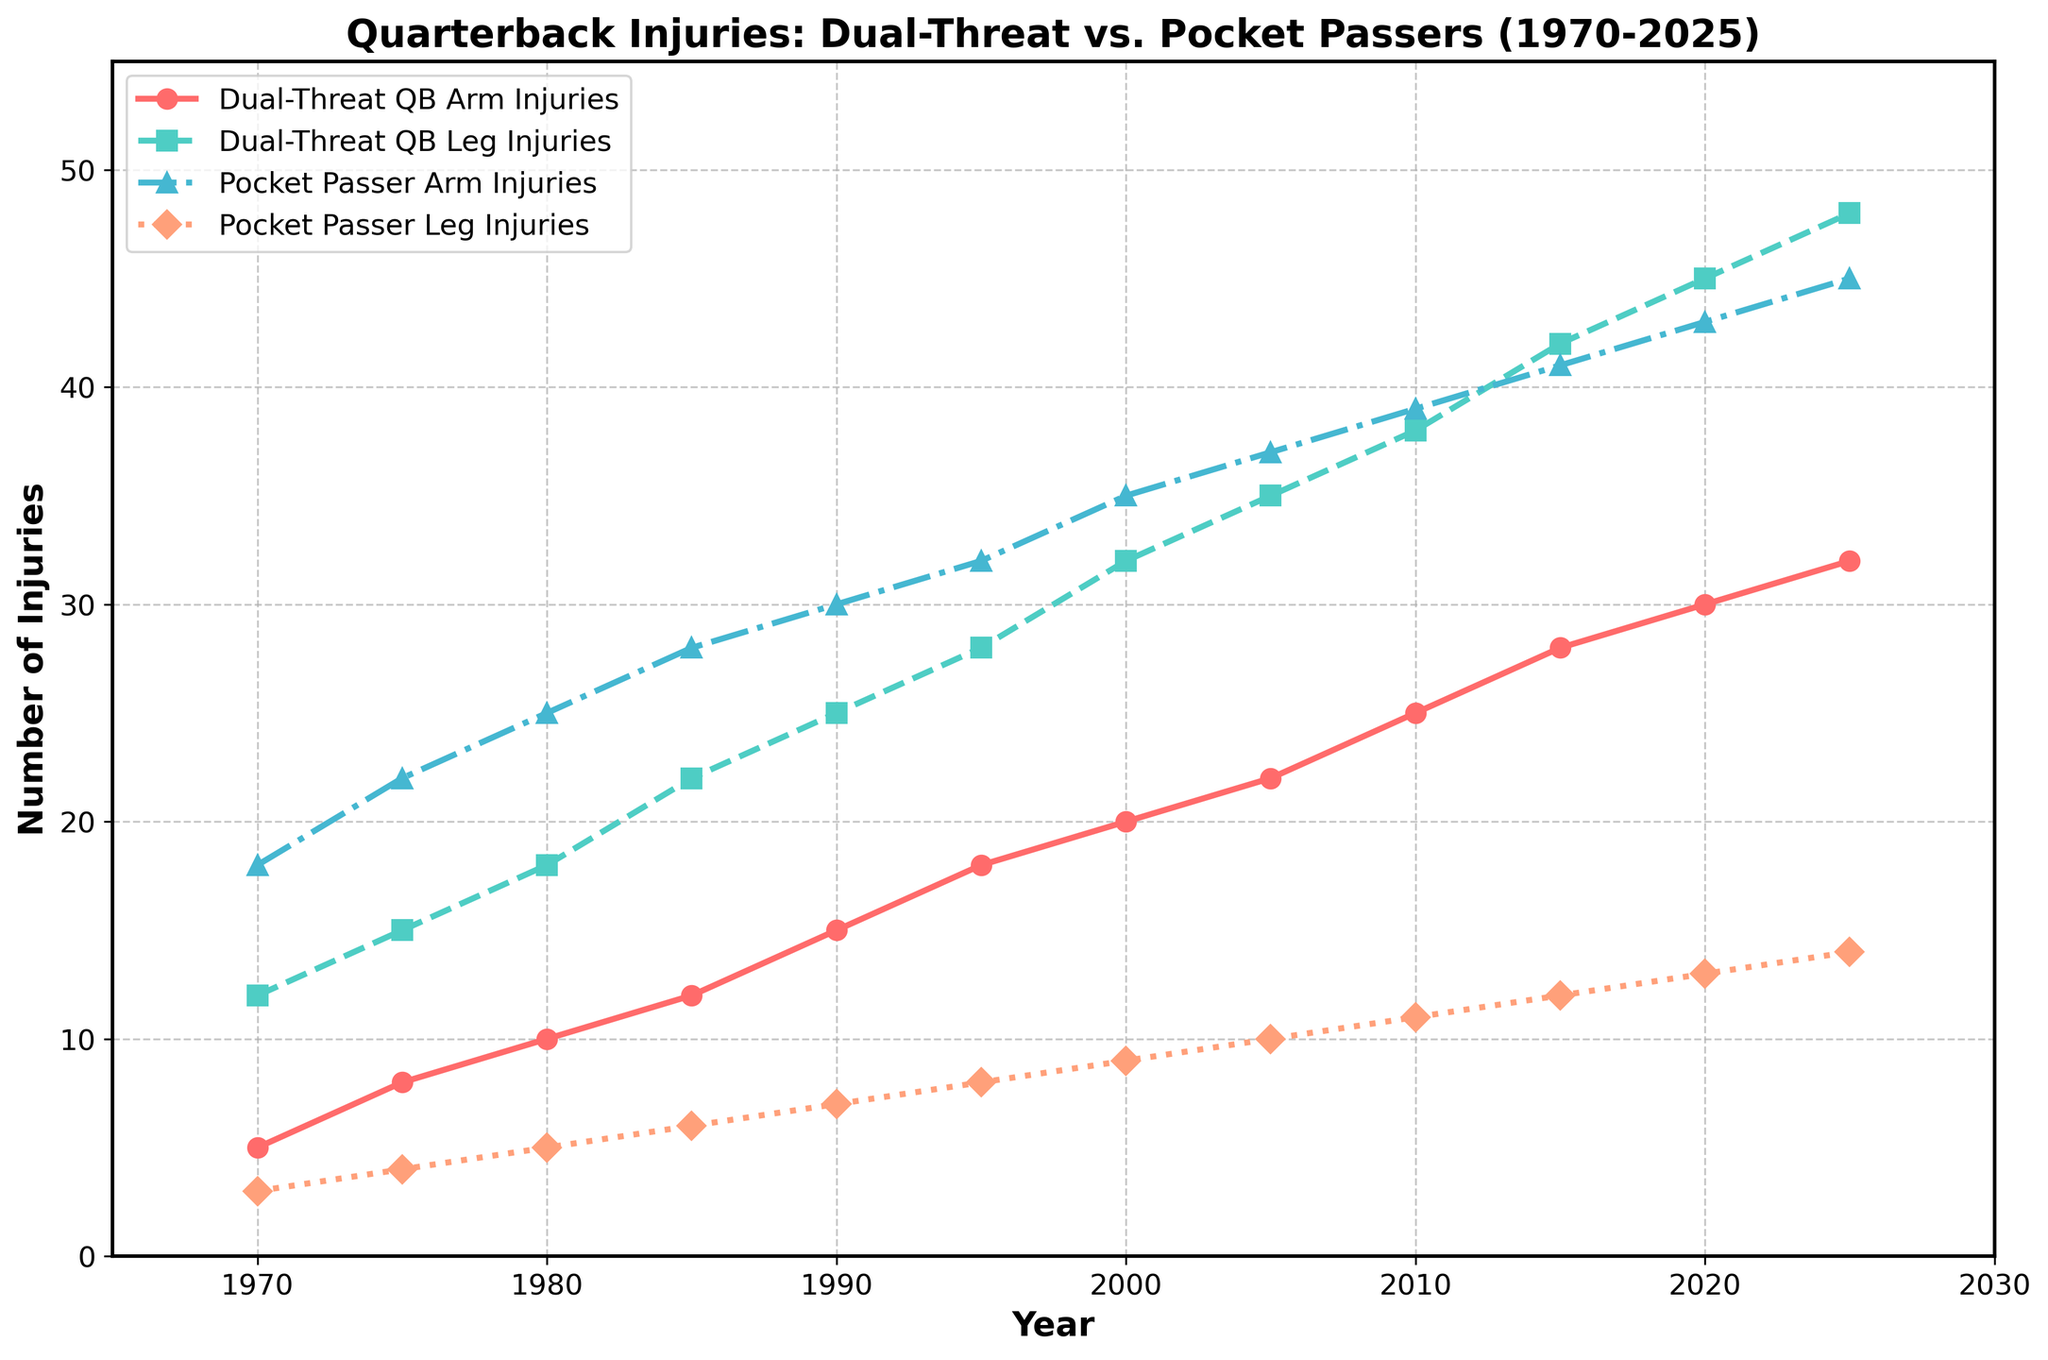Which type of quarterback had more arm injuries in 1980? By looking at the figure, we can see both the line for Dual-Threat QB Arm Injuries (red line with circles) and the line for Pocket Passer Arm Injuries (blue line with triangles). For 1980, the point on the red line is at 10, and the point on the blue line is at 25. Pocket Passer QBs had more arm injuries in 1980
Answer: Pocket Passer QBs In what year did Dual-Threat QBs have 45 leg injuries? Check the green line with squares for Dual-Threat QB Leg Injuries and find the year where the value is 45. The line reaches 45 in the year 2020
Answer: 2020 How many total injuries did Pocket Passer QBs have in 2005? We need to sum the arm and leg injuries for Pocket Passer QBs in 2005. From the figure, arm injuries are at 37, and leg injuries are at 10. So, the total is 37 + 10 = 47
Answer: 47 What is the difference in leg injuries between Dual-Threat and Pocket Passer QBs in 1990? Look for leg injuries for Dual-Threat (green line) and Pocket Passer (orange line) QBs in 1990. Dual-Threat QBs have 25 leg injuries, and Pocket Passer QBs have 7 leg injuries. The difference is 25 - 7 = 18
Answer: 18 Which type of injury has increased more steadily for Dual-Threat QBs over the years? Compare the trends of the red line with circles (Arm injuries) and the green line with squares (Leg injuries) for Dual-Threat QBs over the years. The green line has a more consistent upward trend
Answer: Leg injuries Between 1970 and 2025, for which type of QB have arm injuries increased more drastically? Compare the slope of the red line for Dual-Threat QBs and the blue line for Pocket Passer QBs from 1970 to 2025. The slope of the blue line is steeper
Answer: Pocket Passers By how much did leg injuries for Dual-Threat QBs increase from 1970 to 2025? Note the value for leg injuries for Dual-Threat QBs in 1970 (12) and 2025 (48). Calculate the increase: 48 - 12 = 36
Answer: 36 At which year did arm injuries for both types of QBs reach their respective peak values together? Refer to the highest points on both the red line for Dual-Threat QB Arm Injuries and the blue line for Pocket Passer Arm Injuries on the x-axis. They both peak in 2025
Answer: 2025 